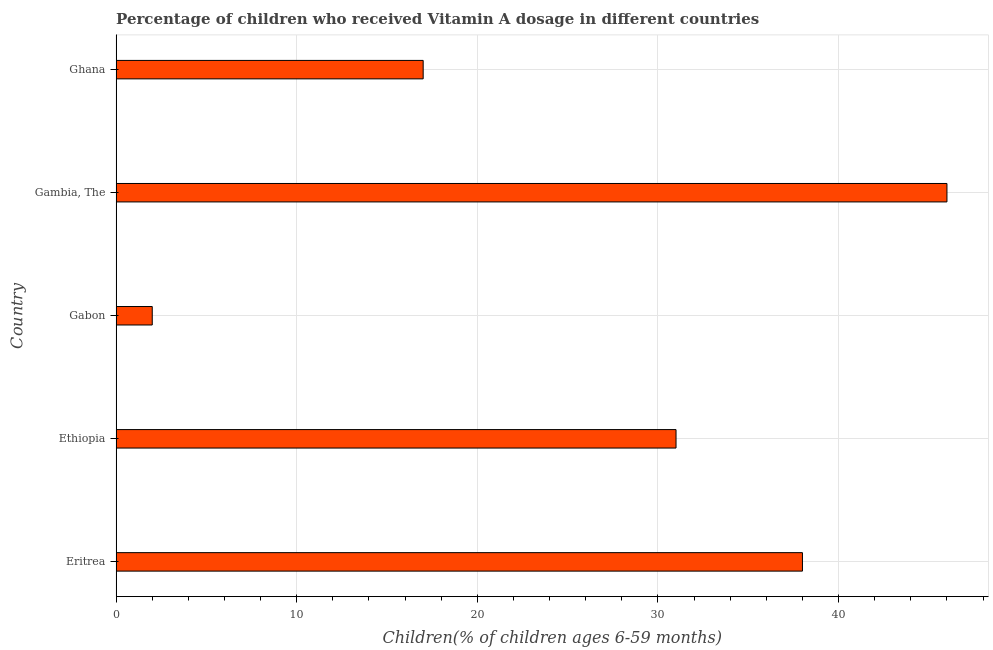Does the graph contain any zero values?
Provide a succinct answer. No. Does the graph contain grids?
Provide a short and direct response. Yes. What is the title of the graph?
Make the answer very short. Percentage of children who received Vitamin A dosage in different countries. What is the label or title of the X-axis?
Your answer should be compact. Children(% of children ages 6-59 months). What is the label or title of the Y-axis?
Ensure brevity in your answer.  Country. What is the vitamin a supplementation coverage rate in Ghana?
Offer a terse response. 17. Across all countries, what is the maximum vitamin a supplementation coverage rate?
Give a very brief answer. 46. Across all countries, what is the minimum vitamin a supplementation coverage rate?
Your response must be concise. 2. In which country was the vitamin a supplementation coverage rate maximum?
Provide a succinct answer. Gambia, The. In which country was the vitamin a supplementation coverage rate minimum?
Keep it short and to the point. Gabon. What is the sum of the vitamin a supplementation coverage rate?
Provide a short and direct response. 134. What is the average vitamin a supplementation coverage rate per country?
Provide a succinct answer. 26.8. What is the median vitamin a supplementation coverage rate?
Provide a short and direct response. 31. In how many countries, is the vitamin a supplementation coverage rate greater than 14 %?
Your answer should be compact. 4. What is the ratio of the vitamin a supplementation coverage rate in Ethiopia to that in Ghana?
Give a very brief answer. 1.82. Is the vitamin a supplementation coverage rate in Gabon less than that in Gambia, The?
Provide a short and direct response. Yes. What is the difference between the highest and the second highest vitamin a supplementation coverage rate?
Keep it short and to the point. 8. What is the difference between the highest and the lowest vitamin a supplementation coverage rate?
Provide a short and direct response. 44. How many bars are there?
Give a very brief answer. 5. What is the Children(% of children ages 6-59 months) in Gabon?
Keep it short and to the point. 2. What is the Children(% of children ages 6-59 months) in Ghana?
Make the answer very short. 17. What is the difference between the Children(% of children ages 6-59 months) in Eritrea and Gambia, The?
Provide a succinct answer. -8. What is the difference between the Children(% of children ages 6-59 months) in Eritrea and Ghana?
Keep it short and to the point. 21. What is the difference between the Children(% of children ages 6-59 months) in Ethiopia and Gabon?
Your answer should be very brief. 29. What is the difference between the Children(% of children ages 6-59 months) in Ethiopia and Ghana?
Ensure brevity in your answer.  14. What is the difference between the Children(% of children ages 6-59 months) in Gabon and Gambia, The?
Give a very brief answer. -44. What is the difference between the Children(% of children ages 6-59 months) in Gambia, The and Ghana?
Provide a succinct answer. 29. What is the ratio of the Children(% of children ages 6-59 months) in Eritrea to that in Ethiopia?
Keep it short and to the point. 1.23. What is the ratio of the Children(% of children ages 6-59 months) in Eritrea to that in Gabon?
Offer a very short reply. 19. What is the ratio of the Children(% of children ages 6-59 months) in Eritrea to that in Gambia, The?
Your response must be concise. 0.83. What is the ratio of the Children(% of children ages 6-59 months) in Eritrea to that in Ghana?
Offer a terse response. 2.23. What is the ratio of the Children(% of children ages 6-59 months) in Ethiopia to that in Gambia, The?
Ensure brevity in your answer.  0.67. What is the ratio of the Children(% of children ages 6-59 months) in Ethiopia to that in Ghana?
Offer a terse response. 1.82. What is the ratio of the Children(% of children ages 6-59 months) in Gabon to that in Gambia, The?
Give a very brief answer. 0.04. What is the ratio of the Children(% of children ages 6-59 months) in Gabon to that in Ghana?
Your response must be concise. 0.12. What is the ratio of the Children(% of children ages 6-59 months) in Gambia, The to that in Ghana?
Provide a short and direct response. 2.71. 